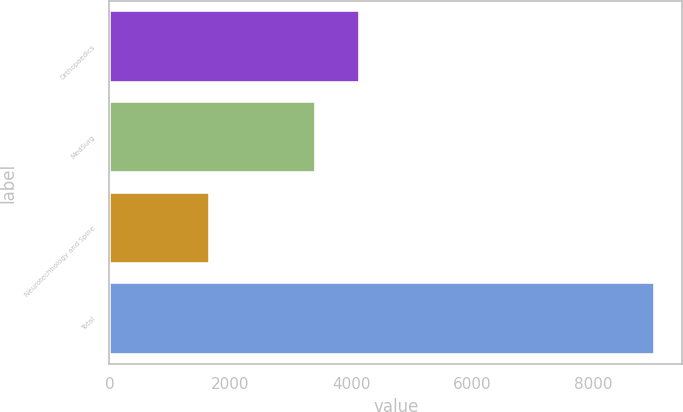<chart> <loc_0><loc_0><loc_500><loc_500><bar_chart><fcel>Orthopaedics<fcel>MedSurg<fcel>Neurotechnology and Spine<fcel>Total<nl><fcel>4150.3<fcel>3414<fcel>1658<fcel>9021<nl></chart> 